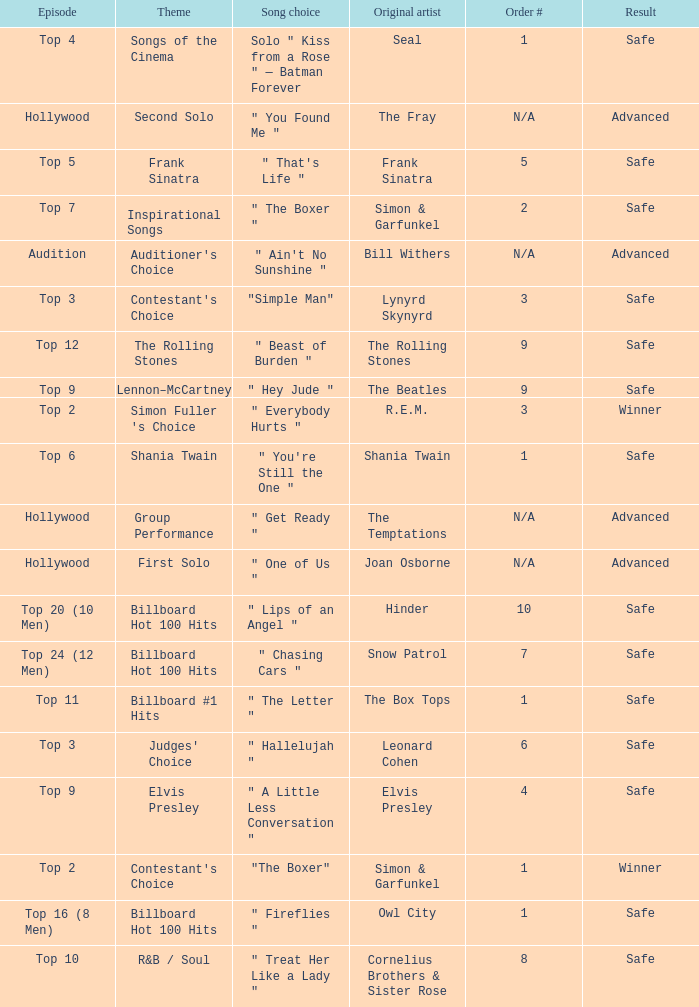The theme Auditioner's Choice	has what song choice? " Ain't No Sunshine ". 